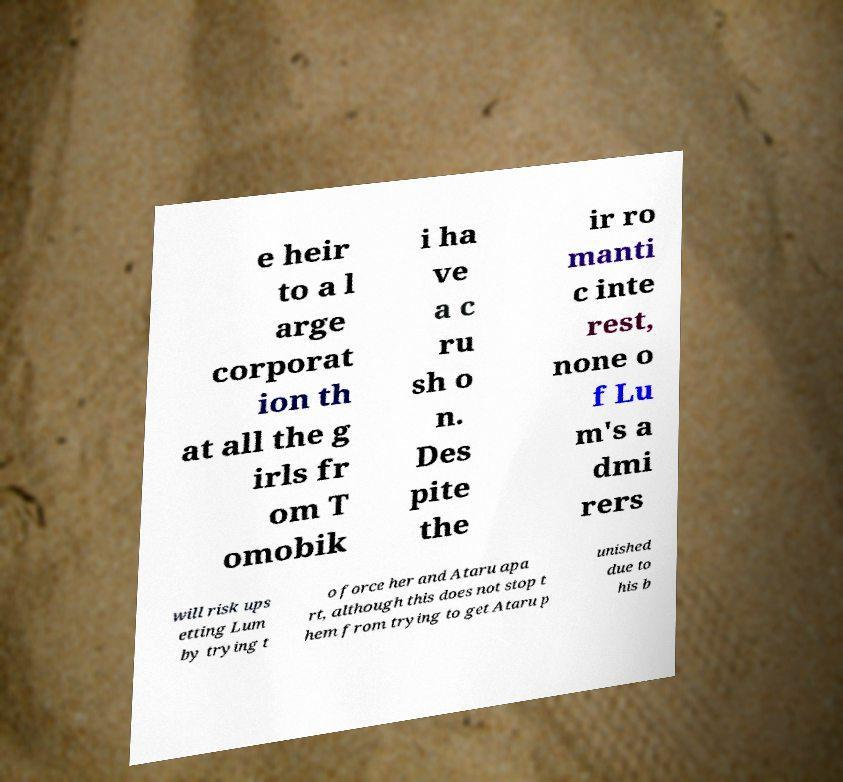I need the written content from this picture converted into text. Can you do that? e heir to a l arge corporat ion th at all the g irls fr om T omobik i ha ve a c ru sh o n. Des pite the ir ro manti c inte rest, none o f Lu m's a dmi rers will risk ups etting Lum by trying t o force her and Ataru apa rt, although this does not stop t hem from trying to get Ataru p unished due to his b 